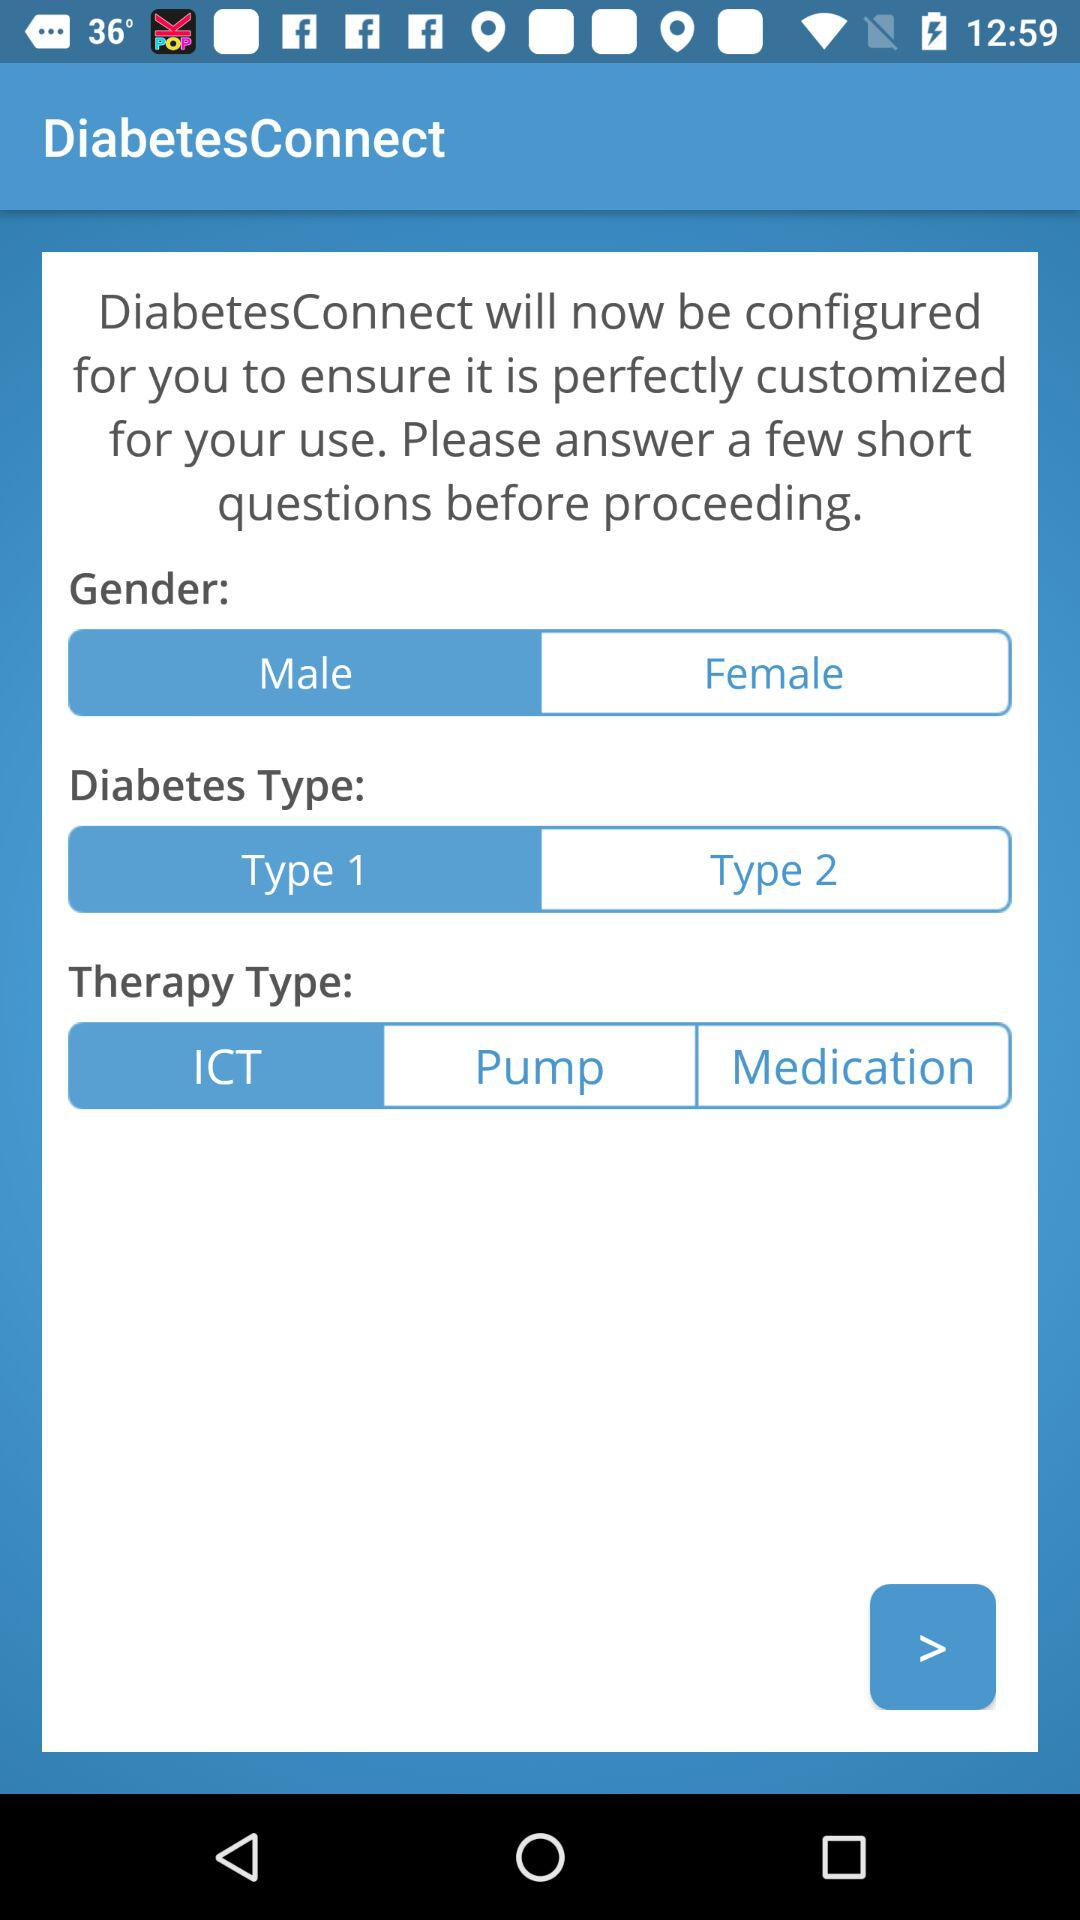What is the type of diabetes? The types of diabetes are "Type 1" and "Type 2". 